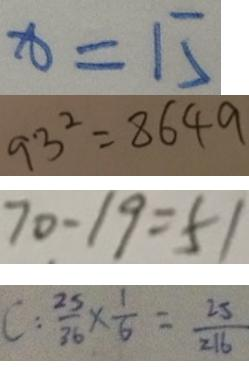<formula> <loc_0><loc_0><loc_500><loc_500>x = 1 5 
 9 3 ^ { 2 } = 8 6 4 9 
 7 0 - 1 9 = 5 1 
 C : \frac { 2 5 } { 3 6 } \times \frac { 1 } { 6 } = \frac { 2 5 } { 2 1 6 }</formula> 